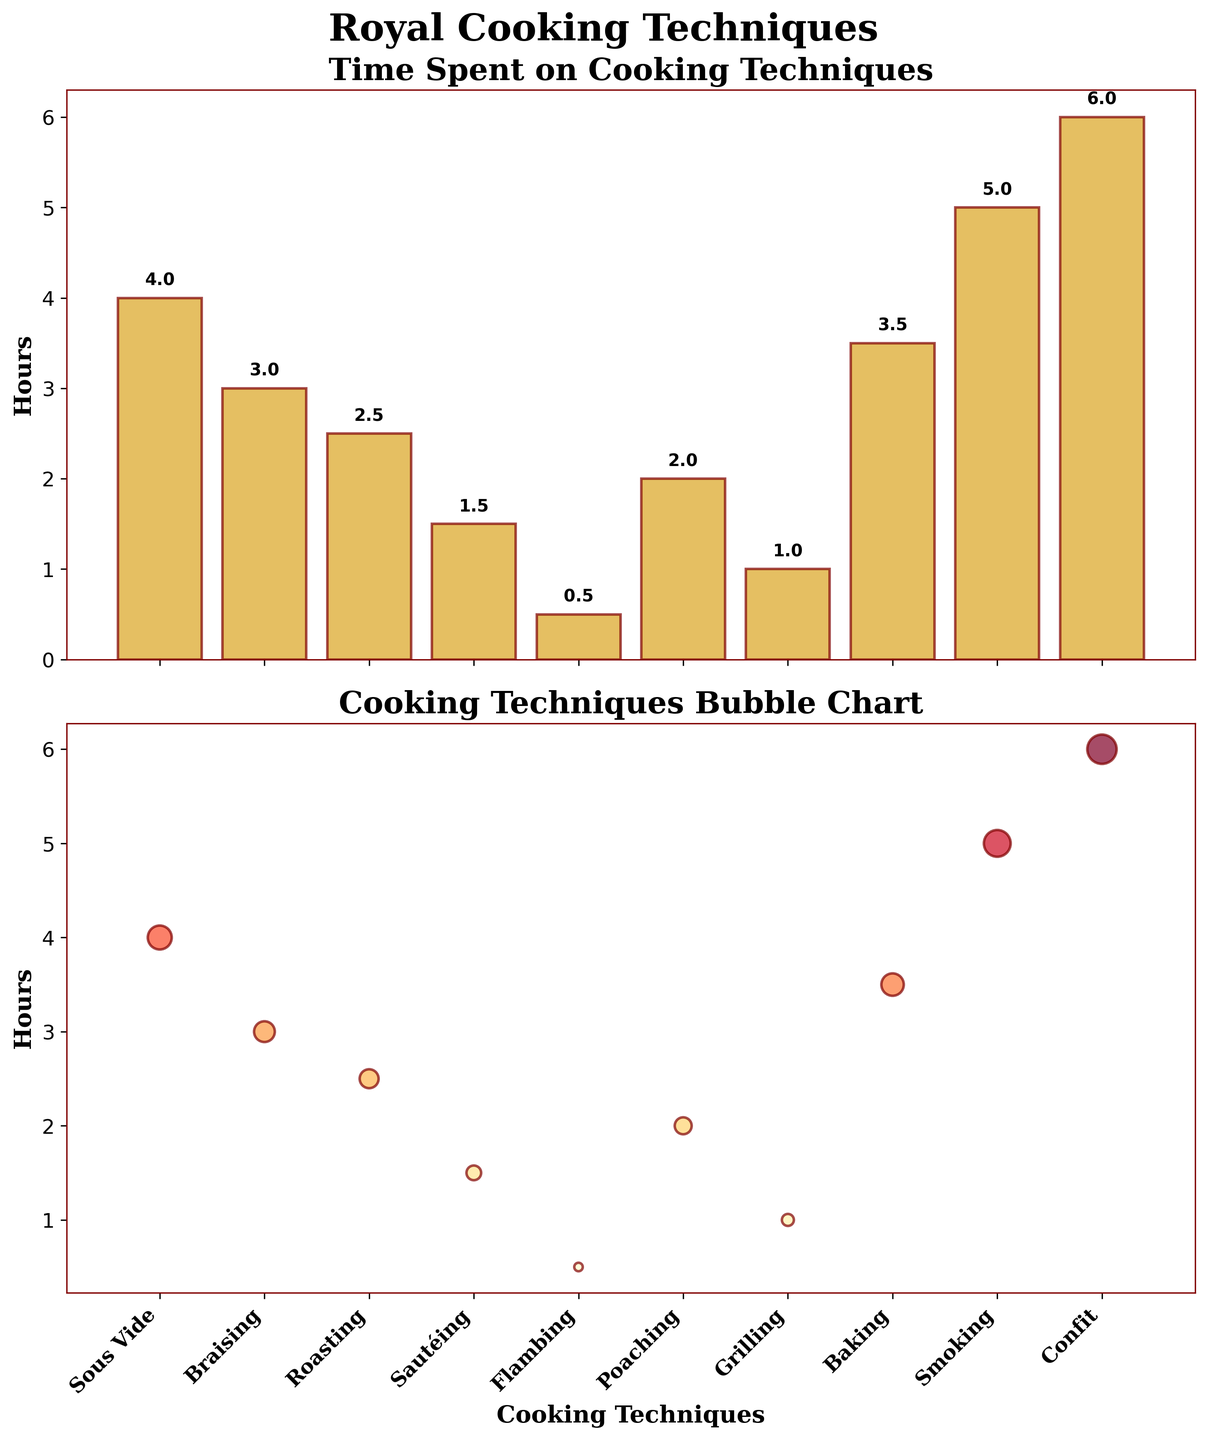What's the total time spent on all the cooking techniques combined? Sum the hours spent on each technique: 4 + 3 + 2.5 + 1.5 + 0.5 + 2 + 1 + 3.5 + 5 + 6 = 29
Answer: 29 Which cooking technique has the maximum number of hours? Look for the tallest bar and the largest bubble. Confit has the max hours at 6 hours.
Answer: Confit How much more time is spent on Smoking compared to Grilling? Subtract the hours for Grilling from the hours for Smoking: 5 - 1 = 4
Answer: 4 What is the average time spent on cooking techniques? Sum the hours and divide by the number of techniques: (4 + 3 + 2.5 + 1.5 + 0.5 + 2 + 1 + 3.5 + 5 + 6) / 10 = 2.9
Answer: 2.9 Which cooking technique involves the least amount of time? Look for the shortest bar and the smallest bubble. Flambing has the least time at 0.5 hours
Answer: Flambing How does the time spent on Baking compare to Braising? Check the bars and bubbles for both. Baking spends 3.5 hours and Braising spends 3 hours. Baking requires 0.5 more hours than Braising.
Answer: Baking spends 0.5 more hours What is the combined time spent on Sous Vide, Smoking, and Confit? Sum the hours for Sous Vide, Smoking, and Confit: 4 + 5 + 6 = 15
Answer: 15 Which technique requires an equal amount of time as Poaching? Look for techniques with the same bar height and bubble size as Poaching (2 hours). Grilling is not equal; no other technique matches Poaching.
Answer: None How many cooking techniques take at least 3 hours? Count the bars and bubbles that represent 3 or more hours: Sous Vide, Braising, Baking, Smoking, and Confit. Total is 5 techniques.
Answer: 5 What's the precise position (x-axis) of the Flambing technique in the scatter plot? Identify the position of Flambing as the fifth technique on the x-axis (indexed from 0)
Answer: 4 